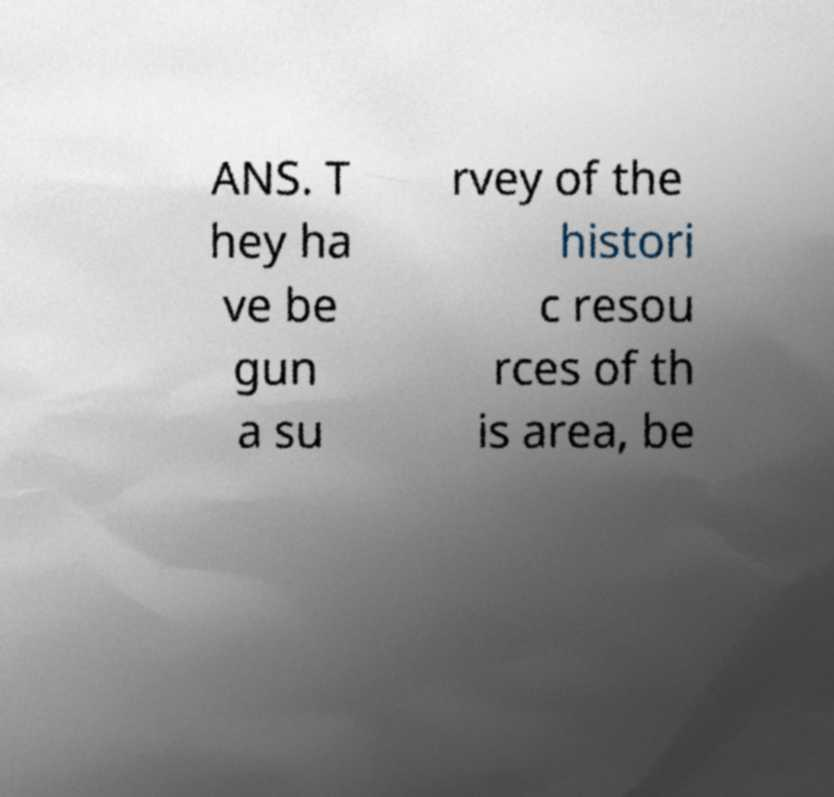Could you assist in decoding the text presented in this image and type it out clearly? ANS. T hey ha ve be gun a su rvey of the histori c resou rces of th is area, be 